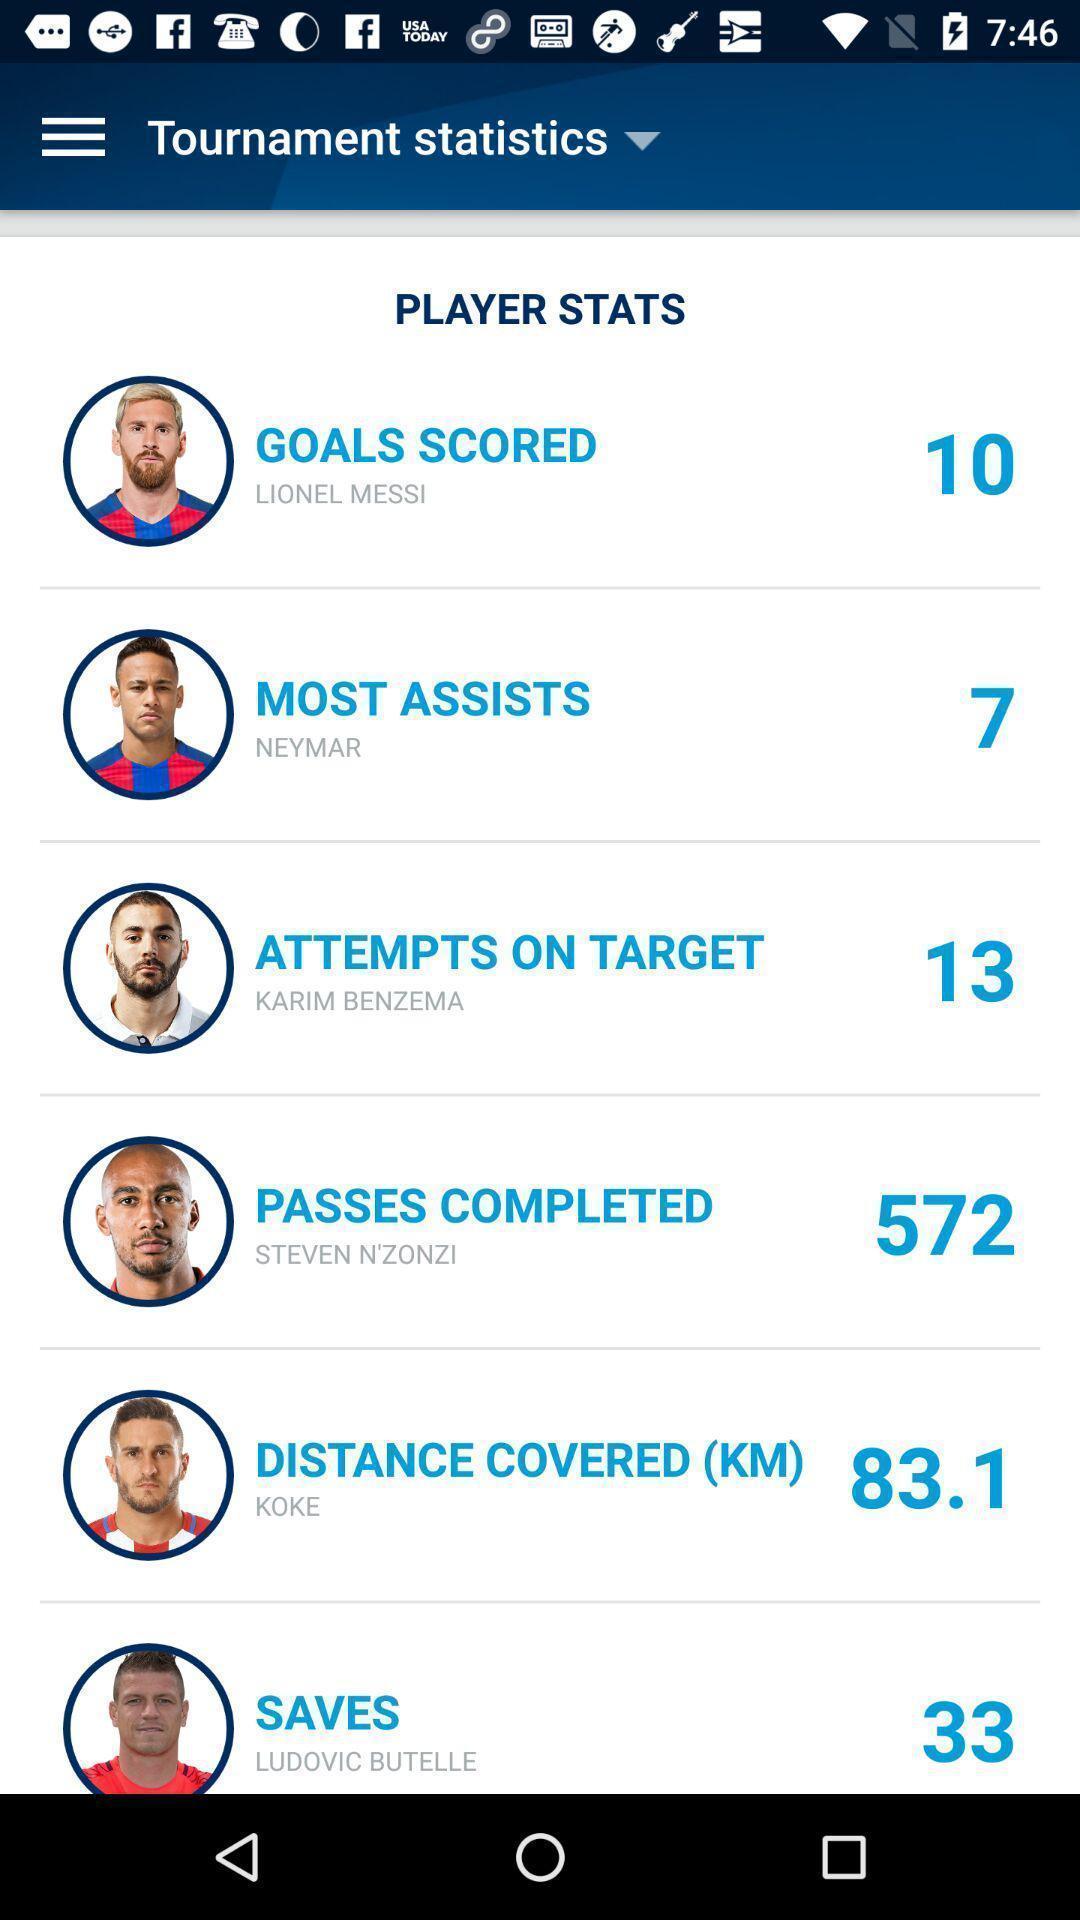Tell me about the visual elements in this screen capture. Page showing scoreboard of players. 